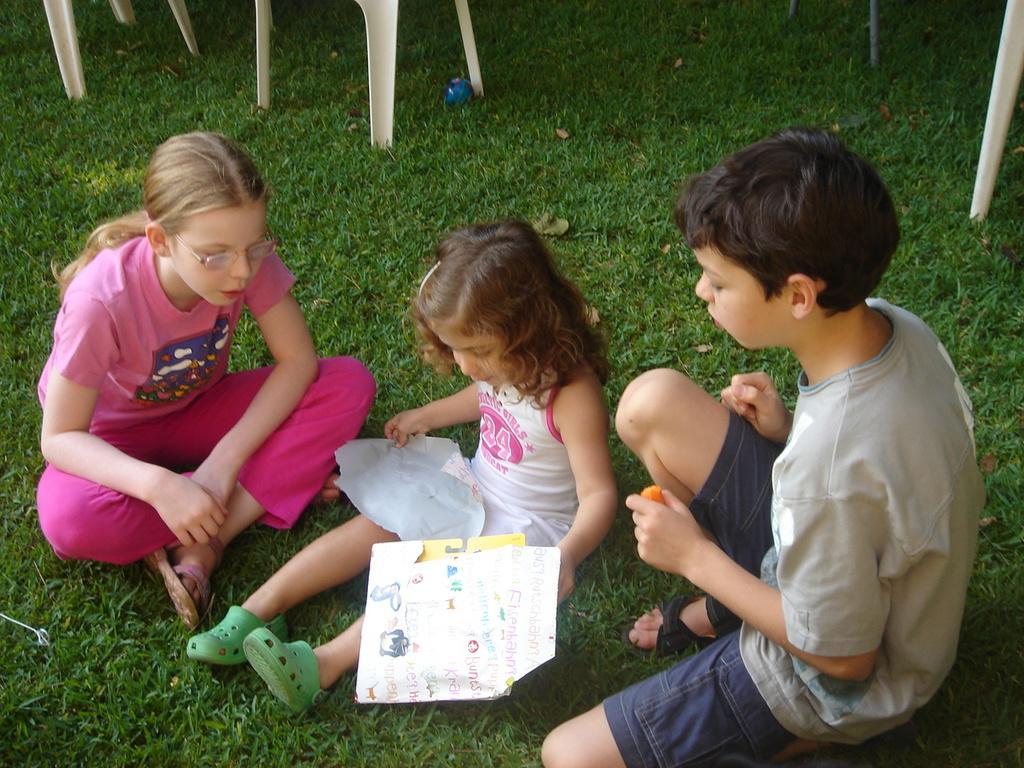How would you summarize this image in a sentence or two? In the image there are two little girls and a boy sitting on the grassland and behind there are chairs. 